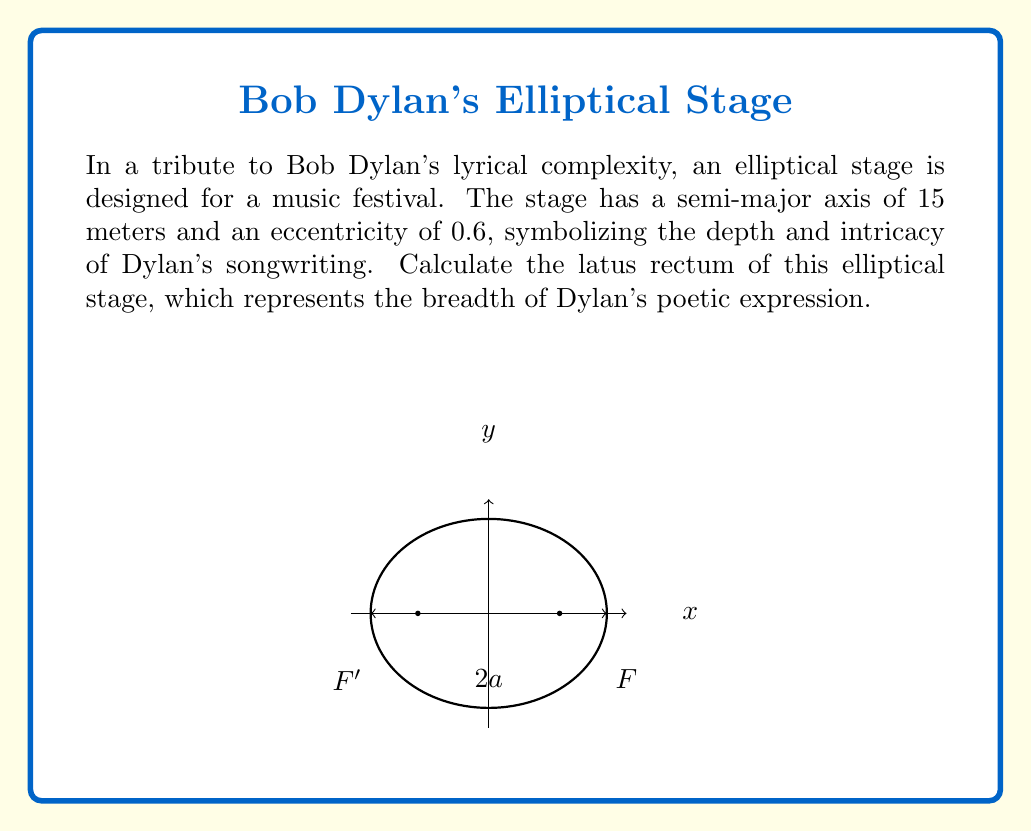Can you solve this math problem? Let's approach this step-by-step:

1) The latus rectum of an ellipse is the chord that passes through a focus and is perpendicular to the major axis. Its length is given by the formula:

   $$ L = \frac{2b^2}{a} $$

   where $L$ is the latus rectum, $b$ is the semi-minor axis, and $a$ is the semi-major axis.

2) We're given that $a = 15$ meters and the eccentricity $e = 0.6$.

3) To find $b$, we can use the relationship between eccentricity, semi-major axis, and semi-minor axis:

   $$ e = \sqrt{1 - \frac{b^2}{a^2}} $$

4) Solving for $b$:
   
   $$ 0.6 = \sqrt{1 - \frac{b^2}{15^2}} $$
   $$ 0.36 = 1 - \frac{b^2}{225} $$
   $$ \frac{b^2}{225} = 0.64 $$
   $$ b^2 = 144 $$
   $$ b = 12 $$

5) Now we can substitute these values into the latus rectum formula:

   $$ L = \frac{2(12^2)}{15} = \frac{288}{15} = 19.2 $$

Therefore, the latus rectum of the elliptical stage is 19.2 meters.
Answer: 19.2 meters 